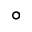Convert formula to latex. <formula><loc_0><loc_0><loc_500><loc_500>^ { \circ }</formula> 